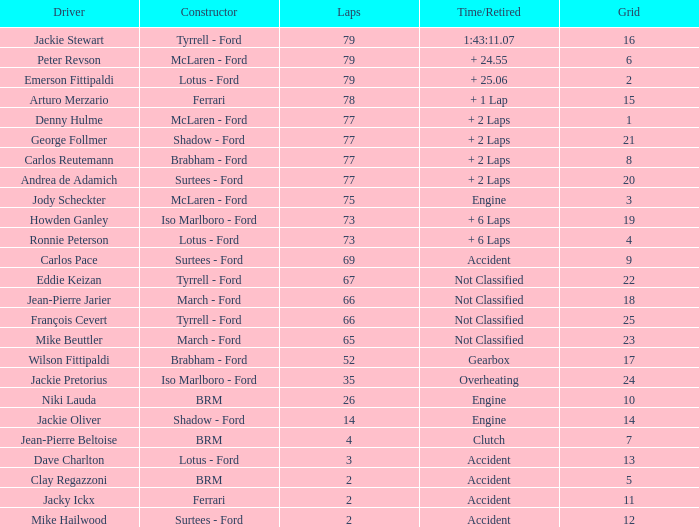What is the entire grid with loops under 2? None. 